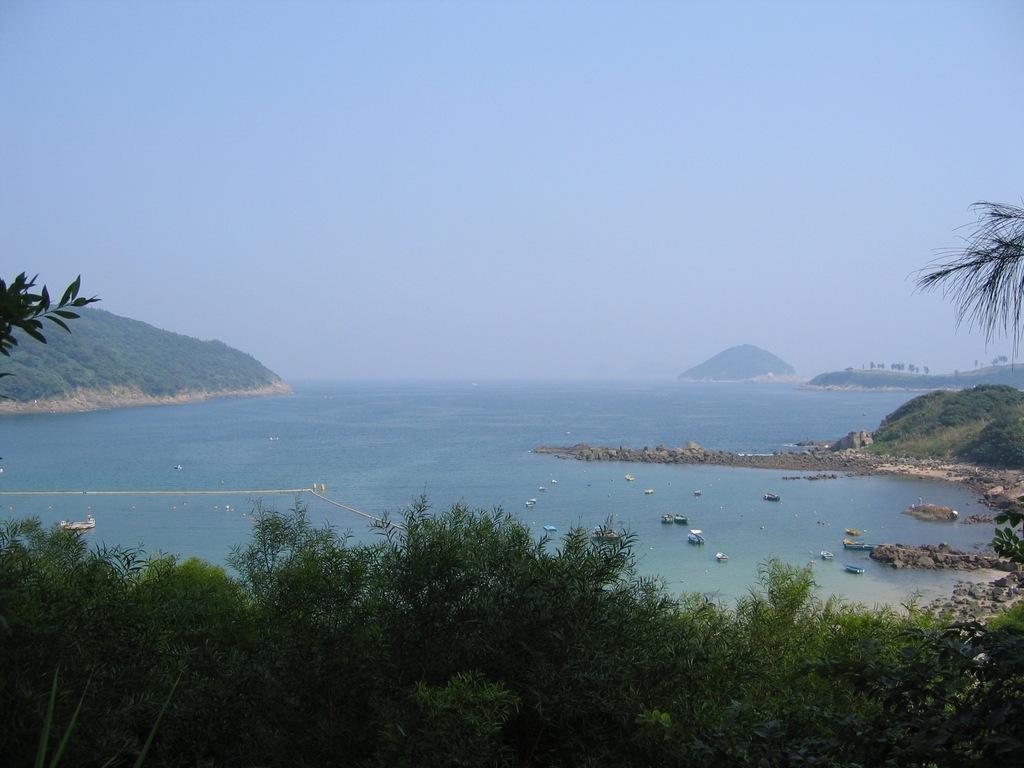Can you describe this image briefly? In this image, we can see trees, mountains, water, boats. Top of the image, there is a sky. 